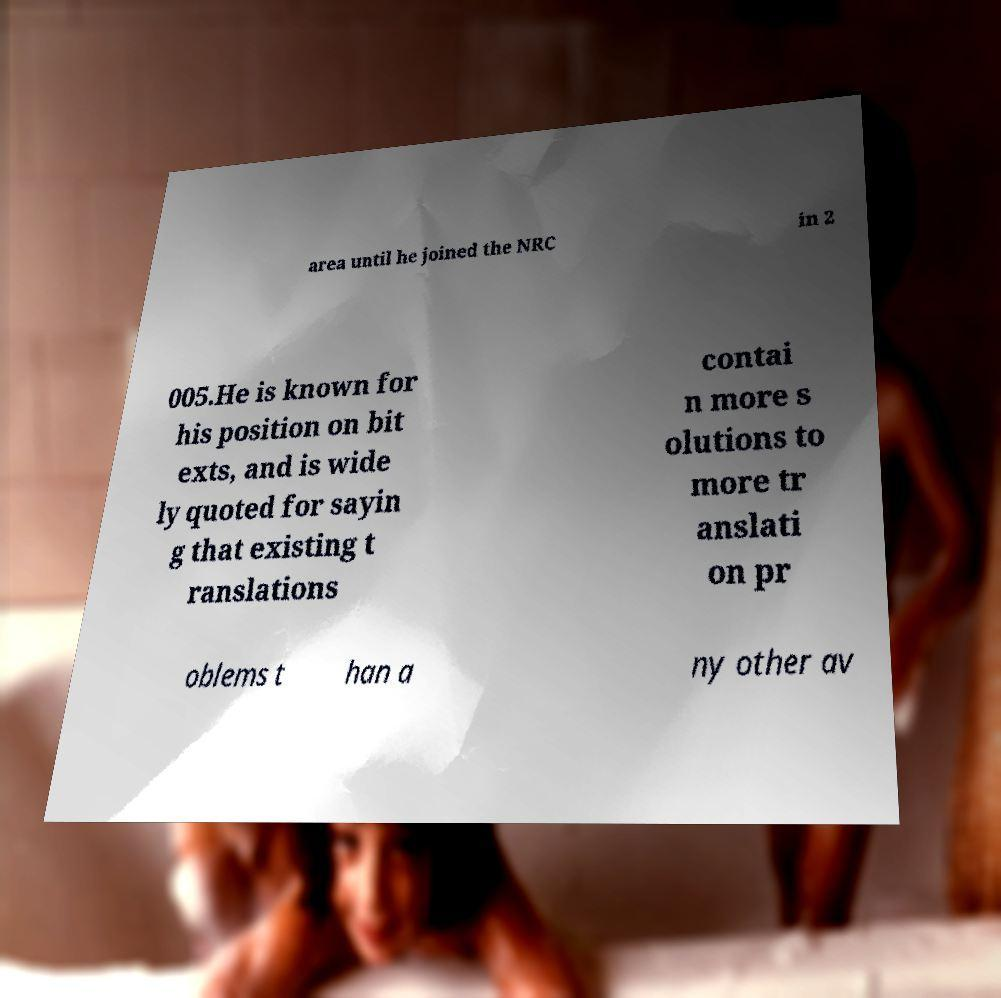Please identify and transcribe the text found in this image. area until he joined the NRC in 2 005.He is known for his position on bit exts, and is wide ly quoted for sayin g that existing t ranslations contai n more s olutions to more tr anslati on pr oblems t han a ny other av 